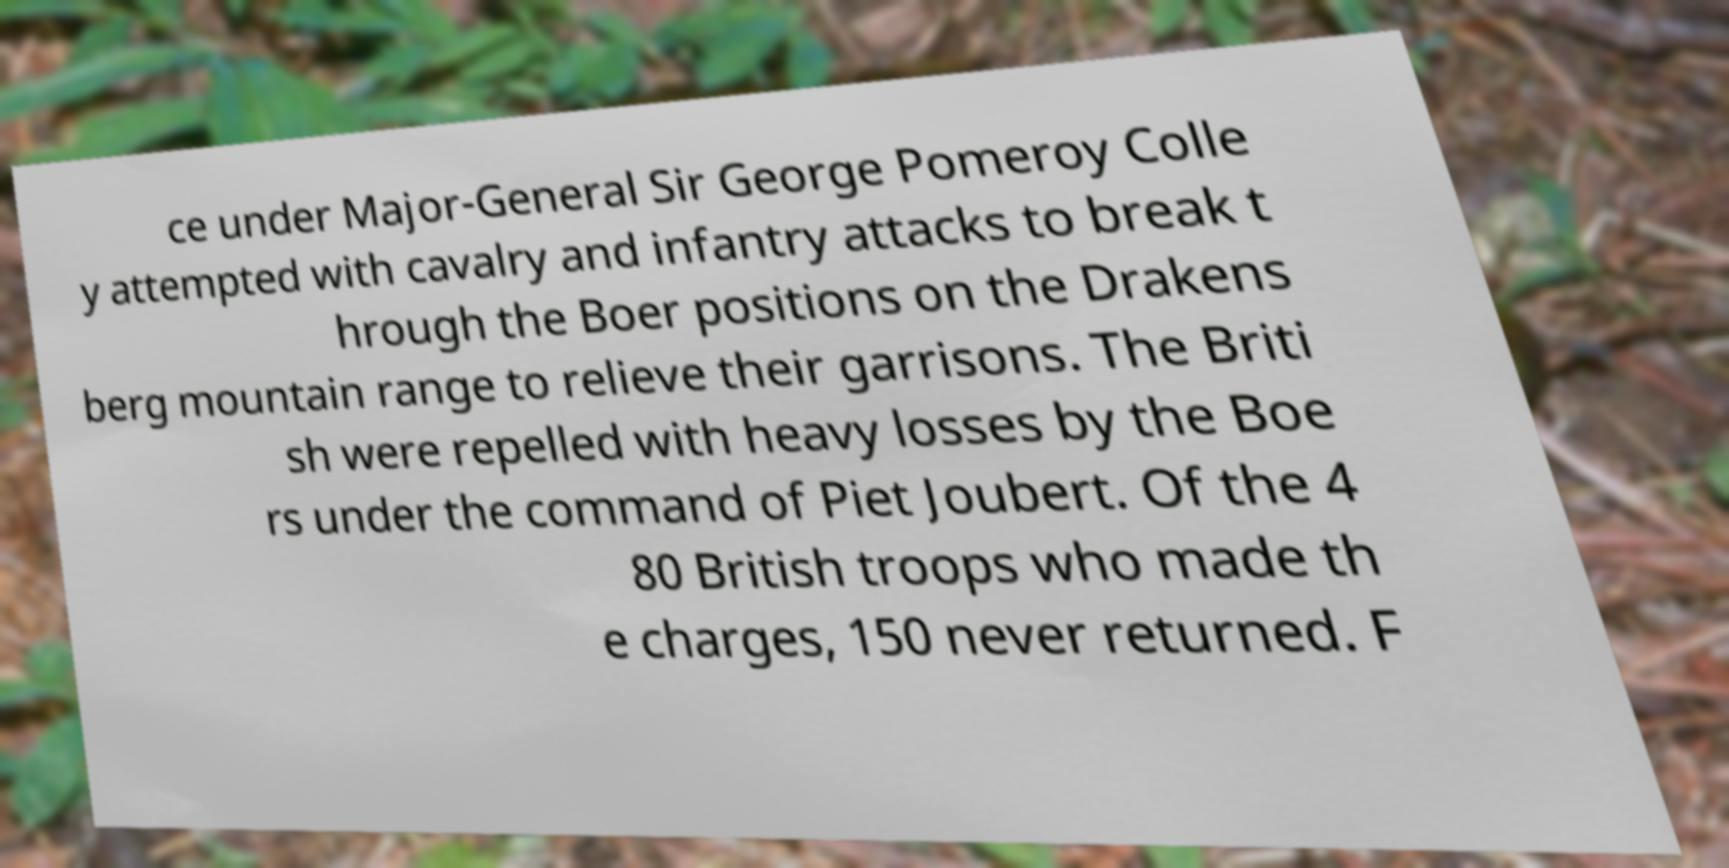Can you read and provide the text displayed in the image?This photo seems to have some interesting text. Can you extract and type it out for me? ce under Major-General Sir George Pomeroy Colle y attempted with cavalry and infantry attacks to break t hrough the Boer positions on the Drakens berg mountain range to relieve their garrisons. The Briti sh were repelled with heavy losses by the Boe rs under the command of Piet Joubert. Of the 4 80 British troops who made th e charges, 150 never returned. F 